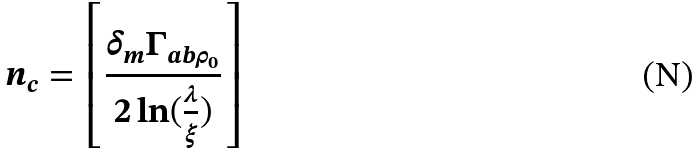Convert formula to latex. <formula><loc_0><loc_0><loc_500><loc_500>n _ { c } = \left [ \frac { \delta _ { m } \Gamma _ { a b \rho _ { 0 } } } { 2 \ln ( \frac { \lambda } { \xi } ) } \right ]</formula> 